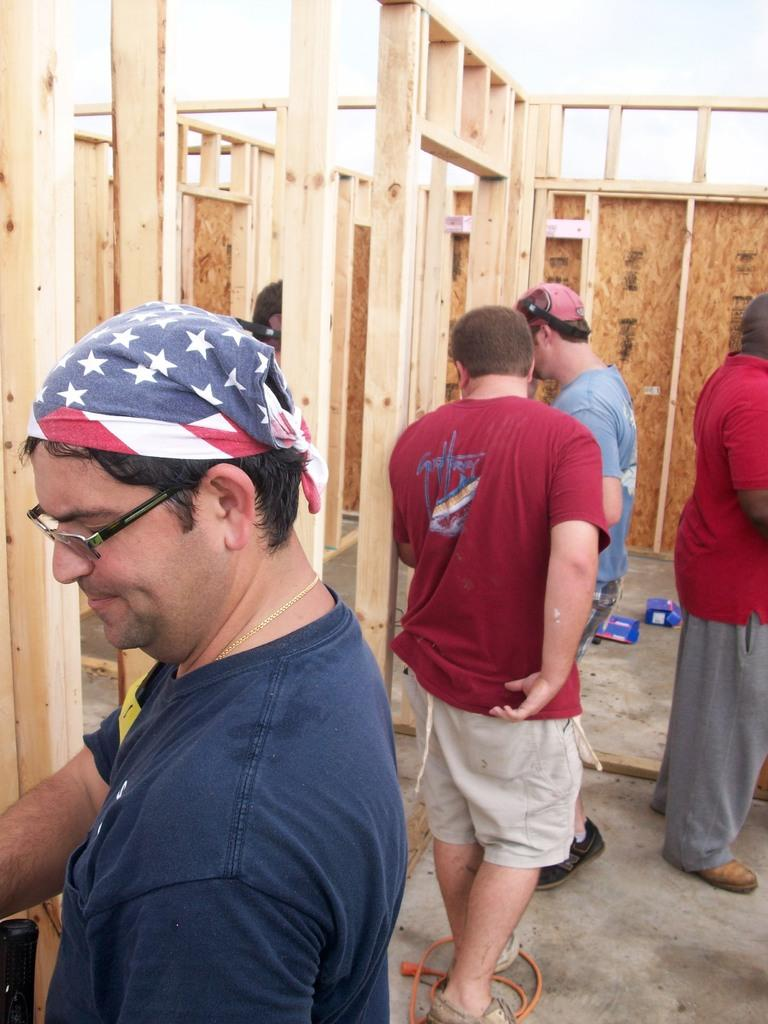What can be seen in the image regarding human subjects? There are men standing in the image. Where are the men positioned in the image? The men are standing on the floor. What else is present on the floor in the image? There are boxes and a wire on the floor. What can be seen in the background of the image? There are wooden walls in the background of the image. What type of instrument is being played by the men in the image? There is no instrument being played by the men in the image; they are simply standing on the floor. 